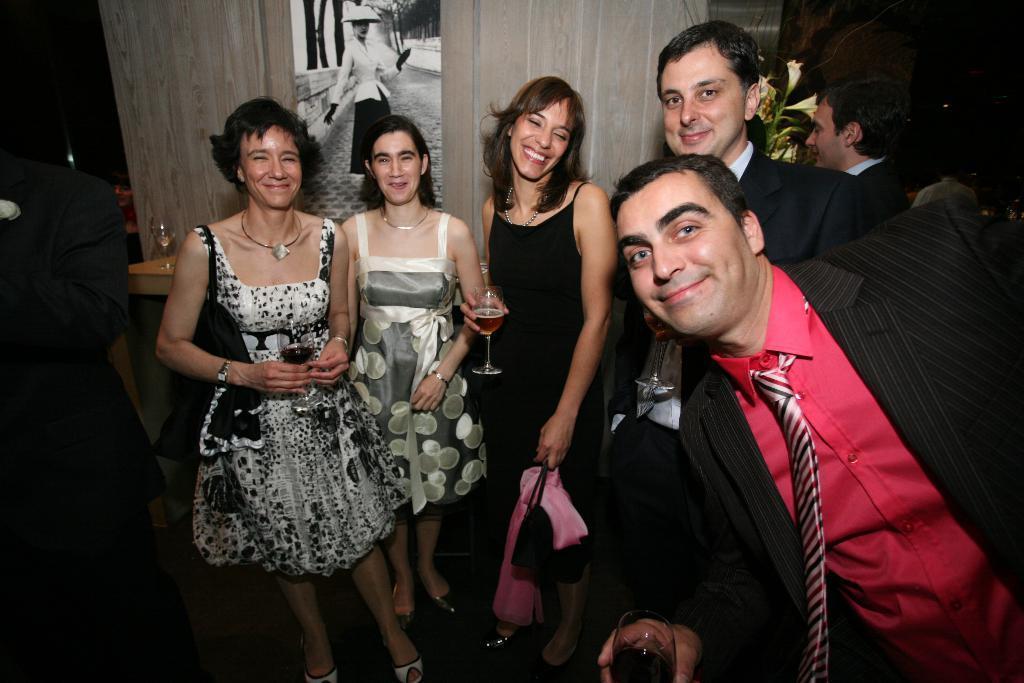Could you give a brief overview of what you see in this image? In this image I can see few people are standing and I can also smile on their faces. In the background I can see a poster on the wall and in the front I can see a man is holding a glass. I can also see few women are holding glasses. On the top right side of this image I can see a plant. 